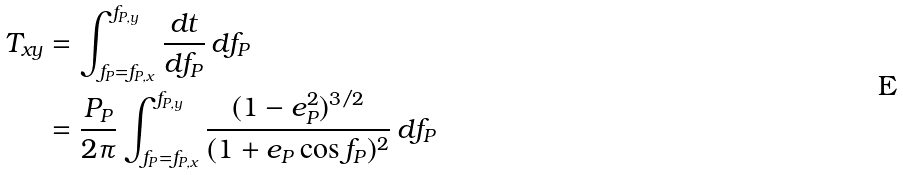Convert formula to latex. <formula><loc_0><loc_0><loc_500><loc_500>T _ { x y } & = \int _ { f _ { P } = f _ { P , x } } ^ { f _ { P , y } } \frac { d t } { d f _ { P } } \, d f _ { P } \\ \quad & = \frac { P _ { P } } { 2 \pi } \int _ { f _ { P } = f _ { P , x } } ^ { f _ { P , y } } \frac { ( 1 - e _ { P } ^ { 2 } ) ^ { 3 / 2 } } { ( 1 + e _ { P } \cos f _ { P } ) ^ { 2 } } \, d f _ { P }</formula> 